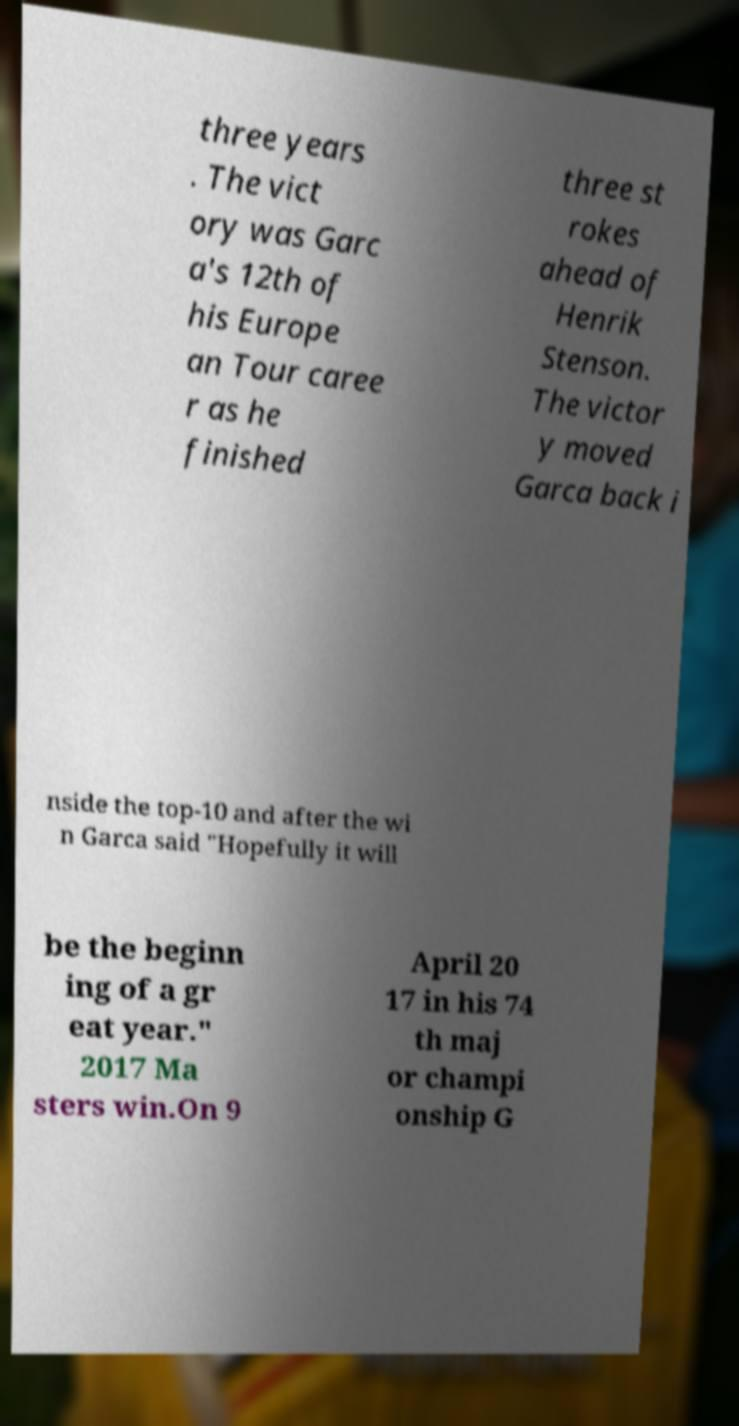Please read and relay the text visible in this image. What does it say? three years . The vict ory was Garc a's 12th of his Europe an Tour caree r as he finished three st rokes ahead of Henrik Stenson. The victor y moved Garca back i nside the top-10 and after the wi n Garca said "Hopefully it will be the beginn ing of a gr eat year." 2017 Ma sters win.On 9 April 20 17 in his 74 th maj or champi onship G 